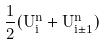Convert formula to latex. <formula><loc_0><loc_0><loc_500><loc_500>\frac { 1 } { 2 } ( U _ { i } ^ { n } + U _ { i \pm 1 } ^ { n } )</formula> 